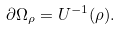Convert formula to latex. <formula><loc_0><loc_0><loc_500><loc_500>\partial \Omega _ { \rho } = U ^ { - 1 } ( \rho ) .</formula> 